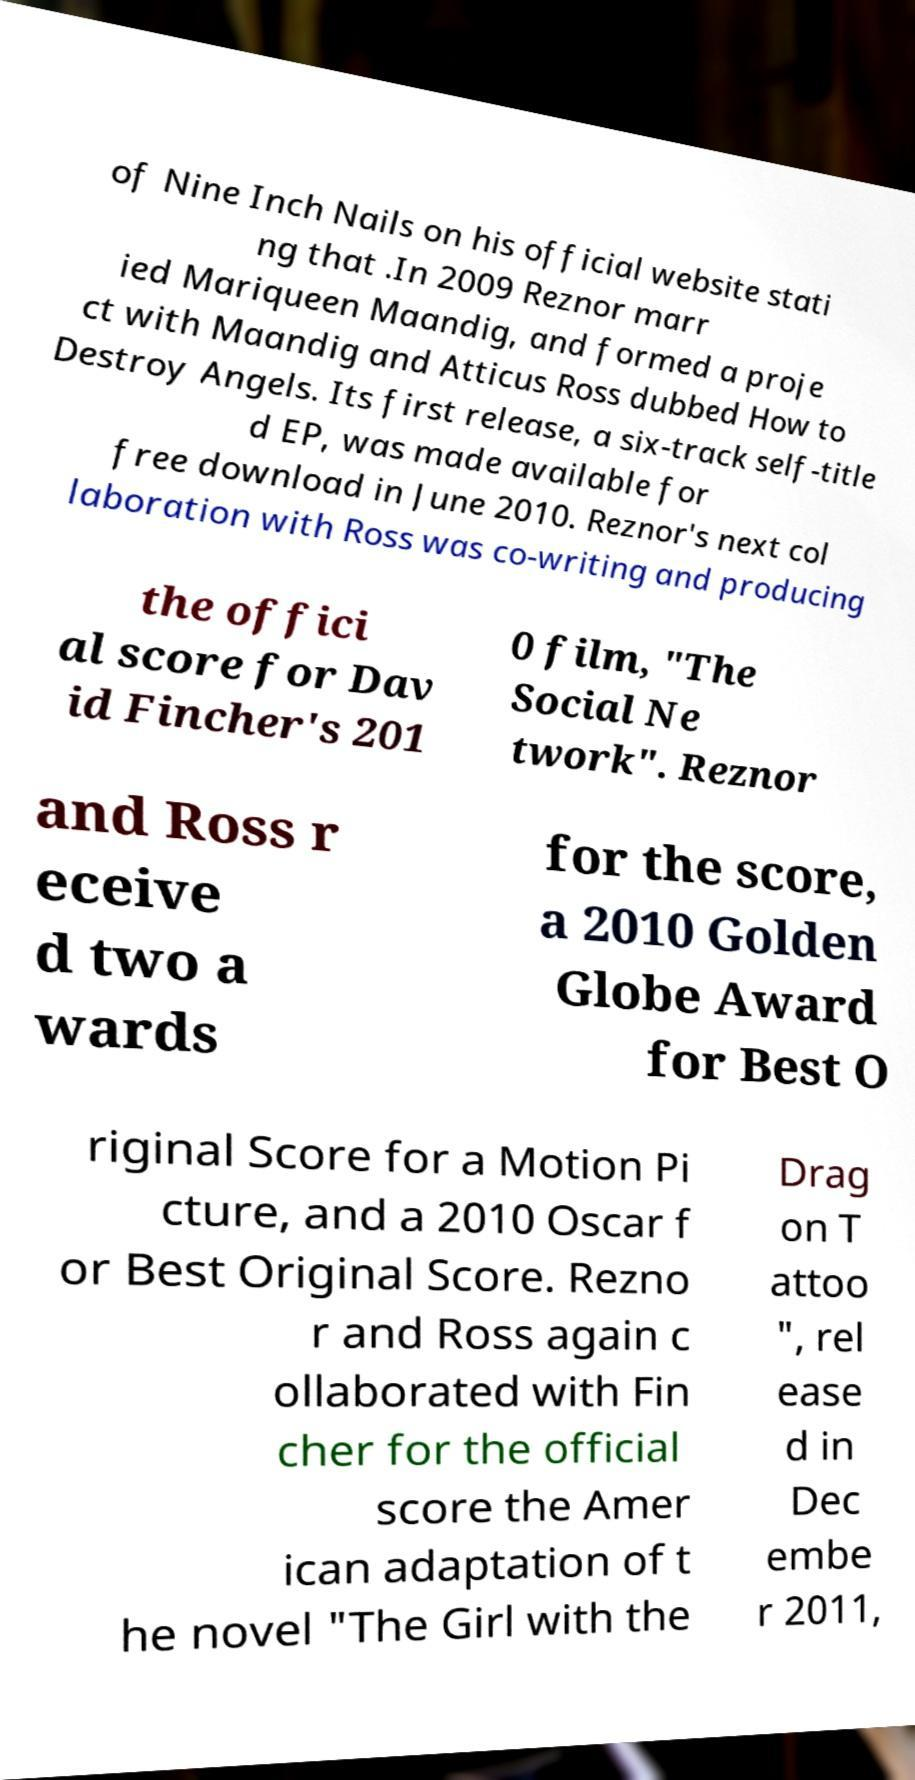Could you extract and type out the text from this image? of Nine Inch Nails on his official website stati ng that .In 2009 Reznor marr ied Mariqueen Maandig, and formed a proje ct with Maandig and Atticus Ross dubbed How to Destroy Angels. Its first release, a six-track self-title d EP, was made available for free download in June 2010. Reznor's next col laboration with Ross was co-writing and producing the offici al score for Dav id Fincher's 201 0 film, "The Social Ne twork". Reznor and Ross r eceive d two a wards for the score, a 2010 Golden Globe Award for Best O riginal Score for a Motion Pi cture, and a 2010 Oscar f or Best Original Score. Rezno r and Ross again c ollaborated with Fin cher for the official score the Amer ican adaptation of t he novel "The Girl with the Drag on T attoo ", rel ease d in Dec embe r 2011, 